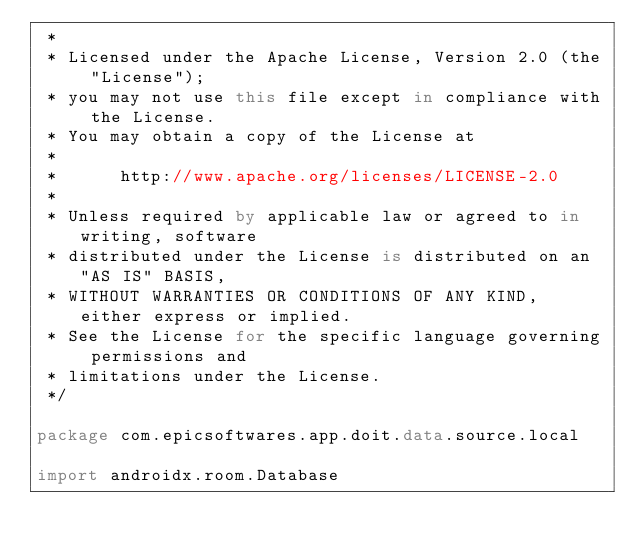<code> <loc_0><loc_0><loc_500><loc_500><_Kotlin_> *
 * Licensed under the Apache License, Version 2.0 (the "License");
 * you may not use this file except in compliance with the License.
 * You may obtain a copy of the License at
 *
 *      http://www.apache.org/licenses/LICENSE-2.0
 *
 * Unless required by applicable law or agreed to in writing, software
 * distributed under the License is distributed on an "AS IS" BASIS,
 * WITHOUT WARRANTIES OR CONDITIONS OF ANY KIND, either express or implied.
 * See the License for the specific language governing permissions and
 * limitations under the License.
 */

package com.epicsoftwares.app.doit.data.source.local

import androidx.room.Database</code> 